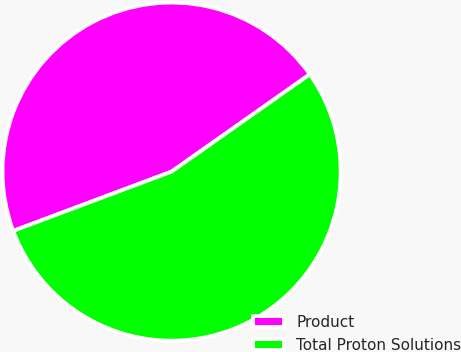Convert chart to OTSL. <chart><loc_0><loc_0><loc_500><loc_500><pie_chart><fcel>Product<fcel>Total Proton Solutions<nl><fcel>45.94%<fcel>54.06%<nl></chart> 